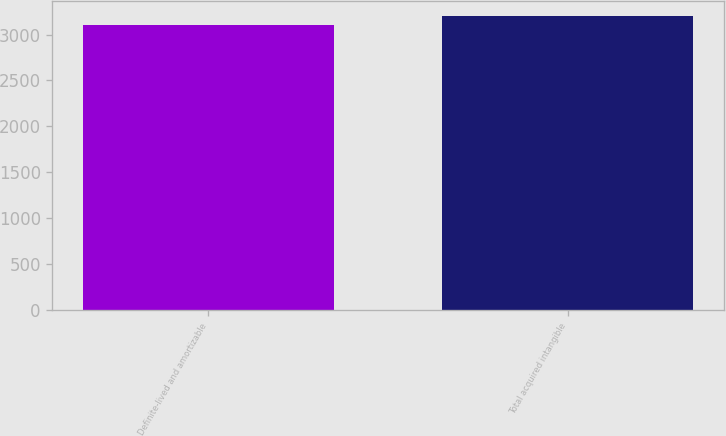<chart> <loc_0><loc_0><loc_500><loc_500><bar_chart><fcel>Definite-lived and amortizable<fcel>Total acquired intangible<nl><fcel>3106<fcel>3206<nl></chart> 